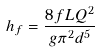<formula> <loc_0><loc_0><loc_500><loc_500>h _ { f } = \frac { 8 f L Q ^ { 2 } } { g \pi ^ { 2 } d ^ { 5 } }</formula> 